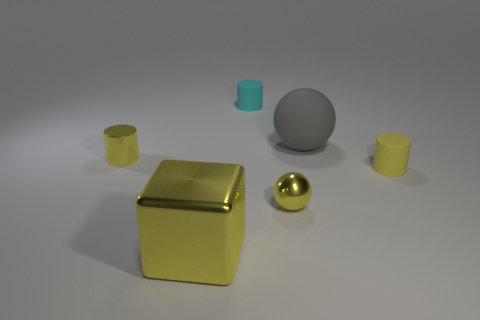Add 3 large metallic things. How many objects exist? 9 Subtract all balls. How many objects are left? 4 Subtract all small cylinders. Subtract all metal blocks. How many objects are left? 2 Add 1 shiny blocks. How many shiny blocks are left? 2 Add 1 yellow shiny cylinders. How many yellow shiny cylinders exist? 2 Subtract 1 yellow blocks. How many objects are left? 5 